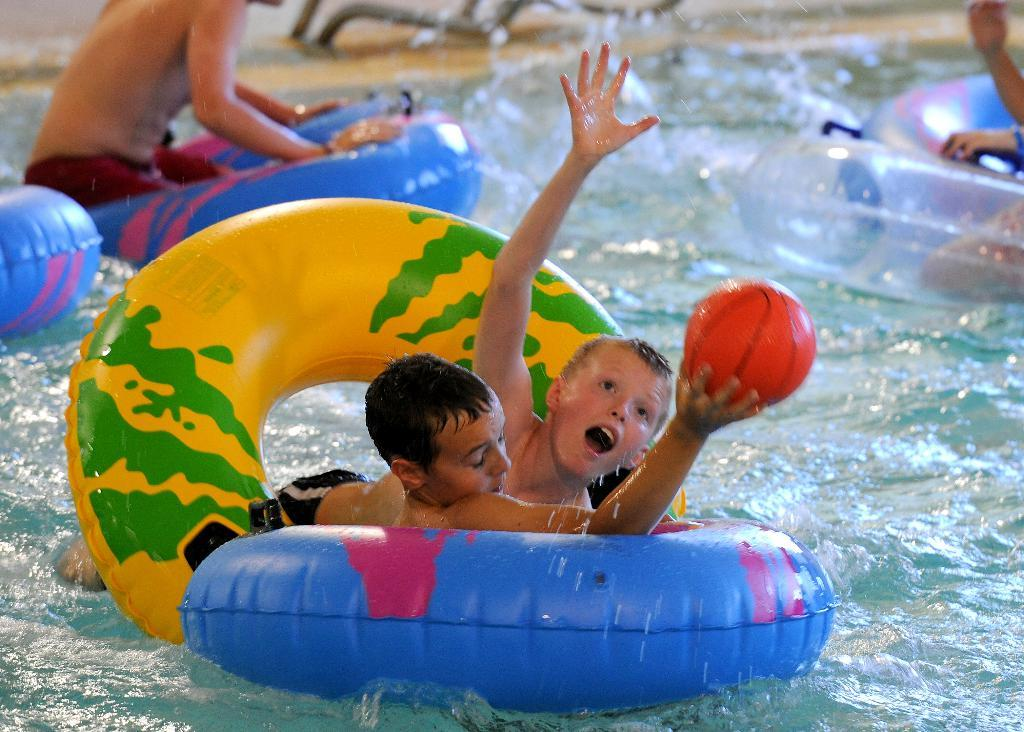What are the people in the image doing? The people in the image are in the water. What objects can be seen in the image besides the people? There are tubes in the image. What is one person holding in the image? One person is holding a ball. What type of tub is present in the image? There is no tub present in the image; it features people in the water and tubes. What occasion is being celebrated in the image? There is no indication of a birthday or any other occasion being celebrated in the image. 